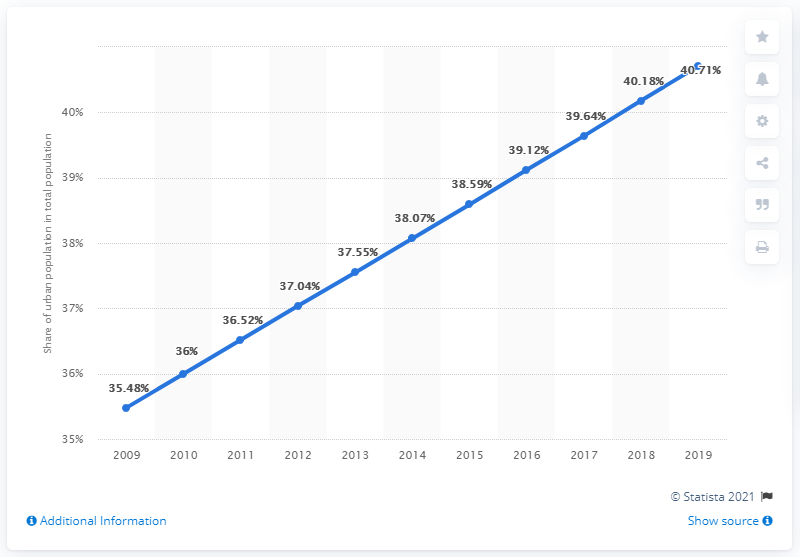List a handful of essential elements in this visual. In the year that the blue line bar crossed the value of 40, it was 2018. The highest population and the lowest population differ significantly. 